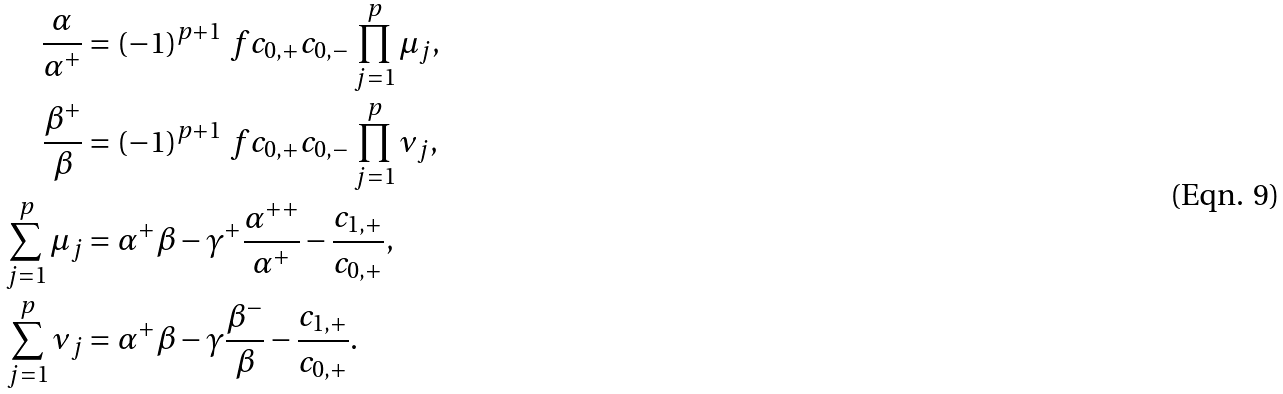<formula> <loc_0><loc_0><loc_500><loc_500>\frac { \alpha } { \alpha ^ { + } } & = ( - 1 ) ^ { p + 1 } \ f { c _ { 0 , + } } { c _ { 0 , - } } \prod _ { j = 1 } ^ { p } \mu _ { j } , \\ \frac { \beta ^ { + } } { \beta } & = ( - 1 ) ^ { p + 1 } \ f { c _ { 0 , + } } { c _ { 0 , - } } \prod _ { j = 1 } ^ { p } \nu _ { j } , \\ \sum _ { j = 1 } ^ { p } \mu _ { j } & = \alpha ^ { + } \beta - \gamma ^ { + } \frac { \alpha ^ { + + } } { \alpha ^ { + } } - \frac { c _ { 1 , + } } { c _ { 0 , + } } , \\ \sum _ { j = 1 } ^ { p } \nu _ { j } & = \alpha ^ { + } \beta - \gamma \frac { \beta ^ { - } } { \beta } - \frac { c _ { 1 , + } } { c _ { 0 , + } } .</formula> 